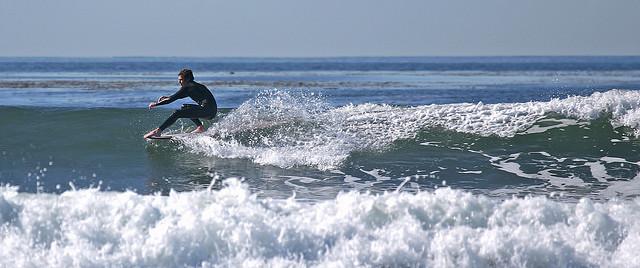Could the person get any closer to the front of the surfboard?
Give a very brief answer. No. Can the surfer be seen clearly?
Give a very brief answer. Yes. How cold is the water?
Concise answer only. Cold. Is the surf rough?
Write a very short answer. No. What color is the water?
Give a very brief answer. Blue. 